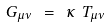<formula> <loc_0><loc_0><loc_500><loc_500>G _ { \mu \nu } \ = \ \kappa \ T _ { \mu \nu }</formula> 